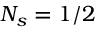Convert formula to latex. <formula><loc_0><loc_0><loc_500><loc_500>N _ { s } = 1 / 2</formula> 